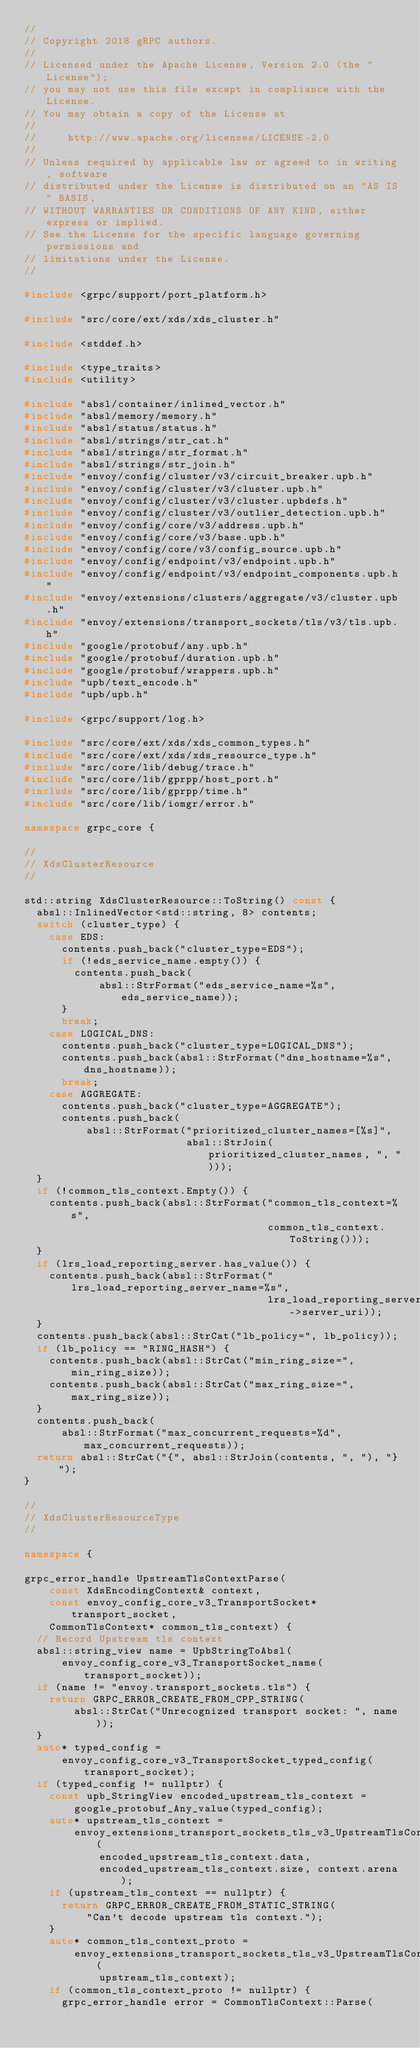<code> <loc_0><loc_0><loc_500><loc_500><_C++_>//
// Copyright 2018 gRPC authors.
//
// Licensed under the Apache License, Version 2.0 (the "License");
// you may not use this file except in compliance with the License.
// You may obtain a copy of the License at
//
//     http://www.apache.org/licenses/LICENSE-2.0
//
// Unless required by applicable law or agreed to in writing, software
// distributed under the License is distributed on an "AS IS" BASIS,
// WITHOUT WARRANTIES OR CONDITIONS OF ANY KIND, either express or implied.
// See the License for the specific language governing permissions and
// limitations under the License.
//

#include <grpc/support/port_platform.h>

#include "src/core/ext/xds/xds_cluster.h"

#include <stddef.h>

#include <type_traits>
#include <utility>

#include "absl/container/inlined_vector.h"
#include "absl/memory/memory.h"
#include "absl/status/status.h"
#include "absl/strings/str_cat.h"
#include "absl/strings/str_format.h"
#include "absl/strings/str_join.h"
#include "envoy/config/cluster/v3/circuit_breaker.upb.h"
#include "envoy/config/cluster/v3/cluster.upb.h"
#include "envoy/config/cluster/v3/cluster.upbdefs.h"
#include "envoy/config/cluster/v3/outlier_detection.upb.h"
#include "envoy/config/core/v3/address.upb.h"
#include "envoy/config/core/v3/base.upb.h"
#include "envoy/config/core/v3/config_source.upb.h"
#include "envoy/config/endpoint/v3/endpoint.upb.h"
#include "envoy/config/endpoint/v3/endpoint_components.upb.h"
#include "envoy/extensions/clusters/aggregate/v3/cluster.upb.h"
#include "envoy/extensions/transport_sockets/tls/v3/tls.upb.h"
#include "google/protobuf/any.upb.h"
#include "google/protobuf/duration.upb.h"
#include "google/protobuf/wrappers.upb.h"
#include "upb/text_encode.h"
#include "upb/upb.h"

#include <grpc/support/log.h>

#include "src/core/ext/xds/xds_common_types.h"
#include "src/core/ext/xds/xds_resource_type.h"
#include "src/core/lib/debug/trace.h"
#include "src/core/lib/gprpp/host_port.h"
#include "src/core/lib/gprpp/time.h"
#include "src/core/lib/iomgr/error.h"

namespace grpc_core {

//
// XdsClusterResource
//

std::string XdsClusterResource::ToString() const {
  absl::InlinedVector<std::string, 8> contents;
  switch (cluster_type) {
    case EDS:
      contents.push_back("cluster_type=EDS");
      if (!eds_service_name.empty()) {
        contents.push_back(
            absl::StrFormat("eds_service_name=%s", eds_service_name));
      }
      break;
    case LOGICAL_DNS:
      contents.push_back("cluster_type=LOGICAL_DNS");
      contents.push_back(absl::StrFormat("dns_hostname=%s", dns_hostname));
      break;
    case AGGREGATE:
      contents.push_back("cluster_type=AGGREGATE");
      contents.push_back(
          absl::StrFormat("prioritized_cluster_names=[%s]",
                          absl::StrJoin(prioritized_cluster_names, ", ")));
  }
  if (!common_tls_context.Empty()) {
    contents.push_back(absl::StrFormat("common_tls_context=%s",
                                       common_tls_context.ToString()));
  }
  if (lrs_load_reporting_server.has_value()) {
    contents.push_back(absl::StrFormat("lrs_load_reporting_server_name=%s",
                                       lrs_load_reporting_server->server_uri));
  }
  contents.push_back(absl::StrCat("lb_policy=", lb_policy));
  if (lb_policy == "RING_HASH") {
    contents.push_back(absl::StrCat("min_ring_size=", min_ring_size));
    contents.push_back(absl::StrCat("max_ring_size=", max_ring_size));
  }
  contents.push_back(
      absl::StrFormat("max_concurrent_requests=%d", max_concurrent_requests));
  return absl::StrCat("{", absl::StrJoin(contents, ", "), "}");
}

//
// XdsClusterResourceType
//

namespace {

grpc_error_handle UpstreamTlsContextParse(
    const XdsEncodingContext& context,
    const envoy_config_core_v3_TransportSocket* transport_socket,
    CommonTlsContext* common_tls_context) {
  // Record Upstream tls context
  absl::string_view name = UpbStringToAbsl(
      envoy_config_core_v3_TransportSocket_name(transport_socket));
  if (name != "envoy.transport_sockets.tls") {
    return GRPC_ERROR_CREATE_FROM_CPP_STRING(
        absl::StrCat("Unrecognized transport socket: ", name));
  }
  auto* typed_config =
      envoy_config_core_v3_TransportSocket_typed_config(transport_socket);
  if (typed_config != nullptr) {
    const upb_StringView encoded_upstream_tls_context =
        google_protobuf_Any_value(typed_config);
    auto* upstream_tls_context =
        envoy_extensions_transport_sockets_tls_v3_UpstreamTlsContext_parse(
            encoded_upstream_tls_context.data,
            encoded_upstream_tls_context.size, context.arena);
    if (upstream_tls_context == nullptr) {
      return GRPC_ERROR_CREATE_FROM_STATIC_STRING(
          "Can't decode upstream tls context.");
    }
    auto* common_tls_context_proto =
        envoy_extensions_transport_sockets_tls_v3_UpstreamTlsContext_common_tls_context(
            upstream_tls_context);
    if (common_tls_context_proto != nullptr) {
      grpc_error_handle error = CommonTlsContext::Parse(</code> 